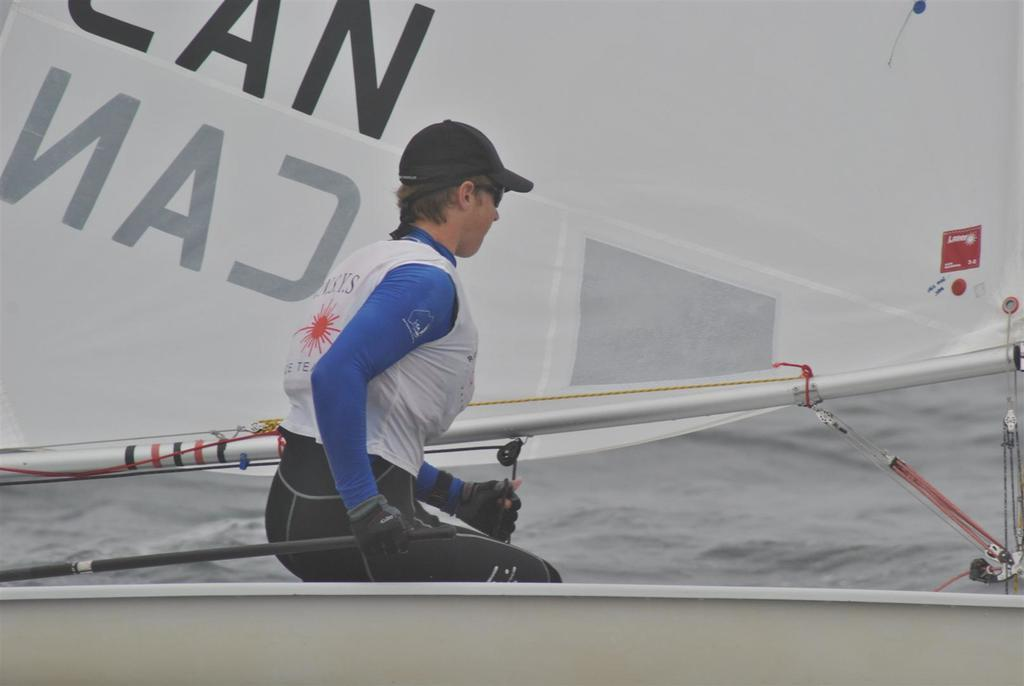Who is present in the image? There is a woman in the image. What is the woman doing in the image? The woman is sitting on a boat. What can be seen behind the woman on the boat? There is a mast behind the woman. What is visible in the background of the image? There is a water surface visible behind the boat. What type of window can be seen in the woman's stomach in the image? There is no window present in the image, and the woman's stomach is not mentioned in the facts provided. 